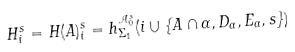Convert formula to latex. <formula><loc_0><loc_0><loc_500><loc_500>H ^ { s } _ { i } = H ( A ) ^ { s } _ { i } = h ^ { \mathcal { A } _ { 0 } ^ { s } } _ { \Sigma _ { 1 } } ( i \cup \{ A \cap \alpha , D _ { \alpha } , E _ { \alpha } , s \} )</formula> 